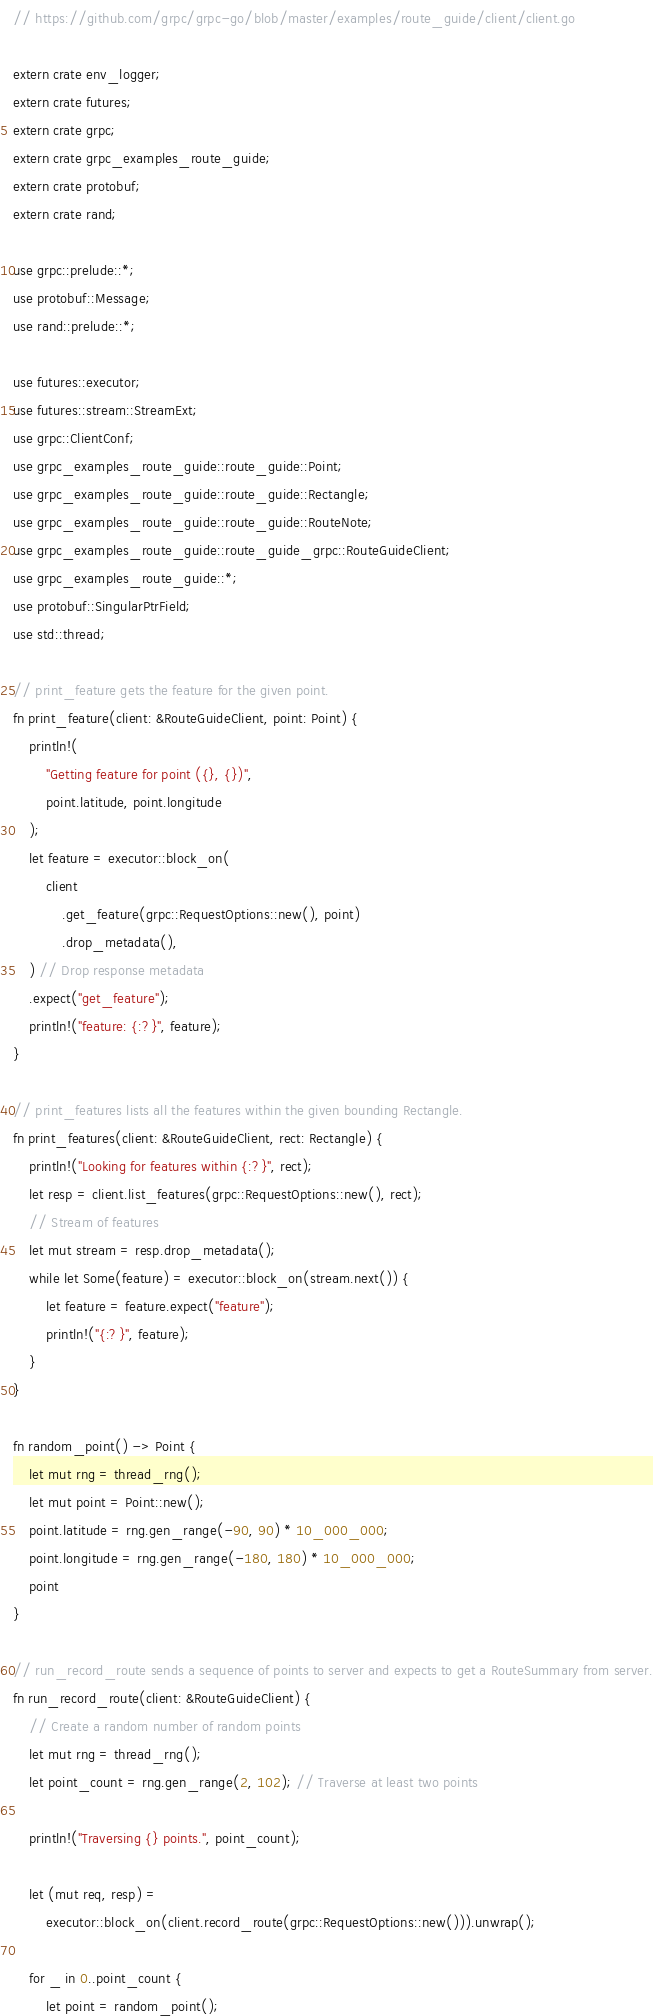Convert code to text. <code><loc_0><loc_0><loc_500><loc_500><_Rust_>// https://github.com/grpc/grpc-go/blob/master/examples/route_guide/client/client.go

extern crate env_logger;
extern crate futures;
extern crate grpc;
extern crate grpc_examples_route_guide;
extern crate protobuf;
extern crate rand;

use grpc::prelude::*;
use protobuf::Message;
use rand::prelude::*;

use futures::executor;
use futures::stream::StreamExt;
use grpc::ClientConf;
use grpc_examples_route_guide::route_guide::Point;
use grpc_examples_route_guide::route_guide::Rectangle;
use grpc_examples_route_guide::route_guide::RouteNote;
use grpc_examples_route_guide::route_guide_grpc::RouteGuideClient;
use grpc_examples_route_guide::*;
use protobuf::SingularPtrField;
use std::thread;

// print_feature gets the feature for the given point.
fn print_feature(client: &RouteGuideClient, point: Point) {
    println!(
        "Getting feature for point ({}, {})",
        point.latitude, point.longitude
    );
    let feature = executor::block_on(
        client
            .get_feature(grpc::RequestOptions::new(), point)
            .drop_metadata(),
    ) // Drop response metadata
    .expect("get_feature");
    println!("feature: {:?}", feature);
}

// print_features lists all the features within the given bounding Rectangle.
fn print_features(client: &RouteGuideClient, rect: Rectangle) {
    println!("Looking for features within {:?}", rect);
    let resp = client.list_features(grpc::RequestOptions::new(), rect);
    // Stream of features
    let mut stream = resp.drop_metadata();
    while let Some(feature) = executor::block_on(stream.next()) {
        let feature = feature.expect("feature");
        println!("{:?}", feature);
    }
}

fn random_point() -> Point {
    let mut rng = thread_rng();
    let mut point = Point::new();
    point.latitude = rng.gen_range(-90, 90) * 10_000_000;
    point.longitude = rng.gen_range(-180, 180) * 10_000_000;
    point
}

// run_record_route sends a sequence of points to server and expects to get a RouteSummary from server.
fn run_record_route(client: &RouteGuideClient) {
    // Create a random number of random points
    let mut rng = thread_rng();
    let point_count = rng.gen_range(2, 102); // Traverse at least two points

    println!("Traversing {} points.", point_count);

    let (mut req, resp) =
        executor::block_on(client.record_route(grpc::RequestOptions::new())).unwrap();

    for _ in 0..point_count {
        let point = random_point();</code> 